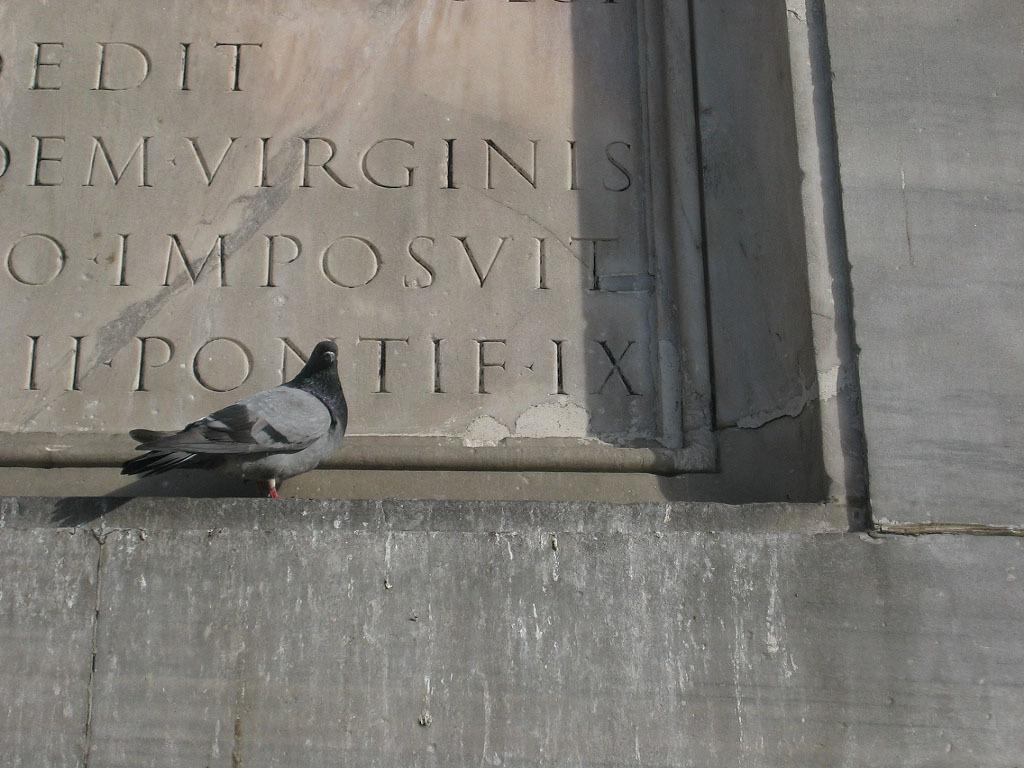What type of bird is on the wall in the image? There is a pigeon on a wall in the image. What is on the wall besides the pigeon? There is text carved on the wall in the image. How many sisters are depicted in the image? There are no sisters present in the image; it features a pigeon on a wall and text carved on the wall. 